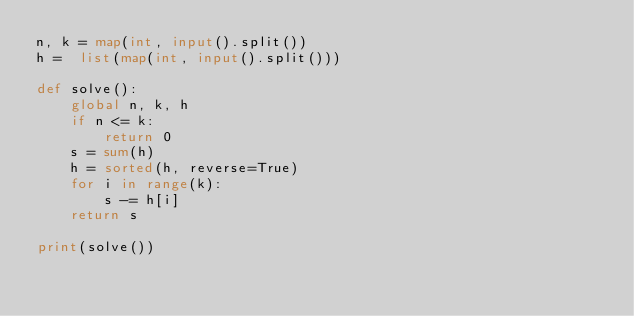<code> <loc_0><loc_0><loc_500><loc_500><_Python_>n, k = map(int, input().split())
h =  list(map(int, input().split()))

def solve():
    global n, k, h
    if n <= k:
        return 0
    s = sum(h)
    h = sorted(h, reverse=True)
    for i in range(k):
        s -= h[i]
    return s

print(solve())</code> 